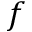Convert formula to latex. <formula><loc_0><loc_0><loc_500><loc_500>f</formula> 